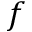Convert formula to latex. <formula><loc_0><loc_0><loc_500><loc_500>f</formula> 